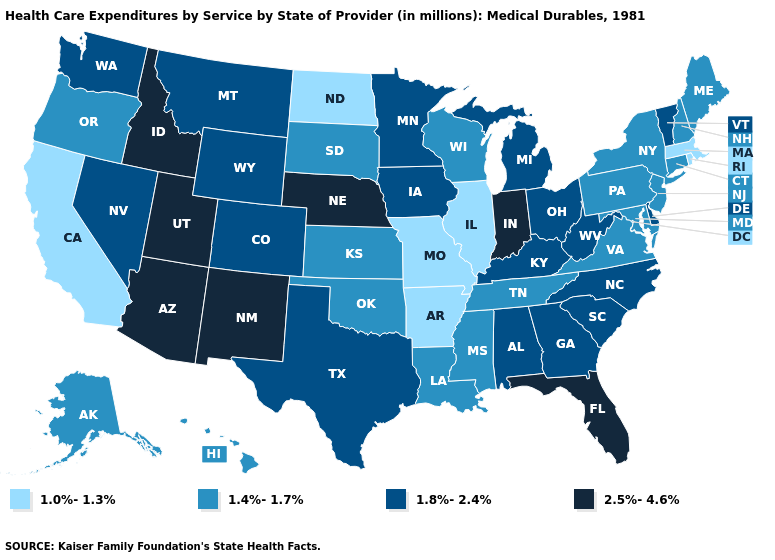Does Indiana have a higher value than Nebraska?
Be succinct. No. Which states have the lowest value in the USA?
Quick response, please. Arkansas, California, Illinois, Massachusetts, Missouri, North Dakota, Rhode Island. Name the states that have a value in the range 2.5%-4.6%?
Give a very brief answer. Arizona, Florida, Idaho, Indiana, Nebraska, New Mexico, Utah. What is the lowest value in the West?
Write a very short answer. 1.0%-1.3%. Which states have the lowest value in the USA?
Quick response, please. Arkansas, California, Illinois, Massachusetts, Missouri, North Dakota, Rhode Island. Among the states that border Rhode Island , does Massachusetts have the lowest value?
Short answer required. Yes. What is the highest value in the USA?
Answer briefly. 2.5%-4.6%. What is the value of Connecticut?
Be succinct. 1.4%-1.7%. What is the value of Massachusetts?
Short answer required. 1.0%-1.3%. Is the legend a continuous bar?
Be succinct. No. Among the states that border Virginia , does Kentucky have the lowest value?
Answer briefly. No. What is the lowest value in the USA?
Keep it brief. 1.0%-1.3%. What is the value of Arizona?
Quick response, please. 2.5%-4.6%. Among the states that border Virginia , does Tennessee have the lowest value?
Keep it brief. Yes. Name the states that have a value in the range 1.0%-1.3%?
Be succinct. Arkansas, California, Illinois, Massachusetts, Missouri, North Dakota, Rhode Island. 